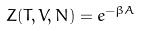<formula> <loc_0><loc_0><loc_500><loc_500>Z ( T , V , N ) = e ^ { - \beta A }</formula> 